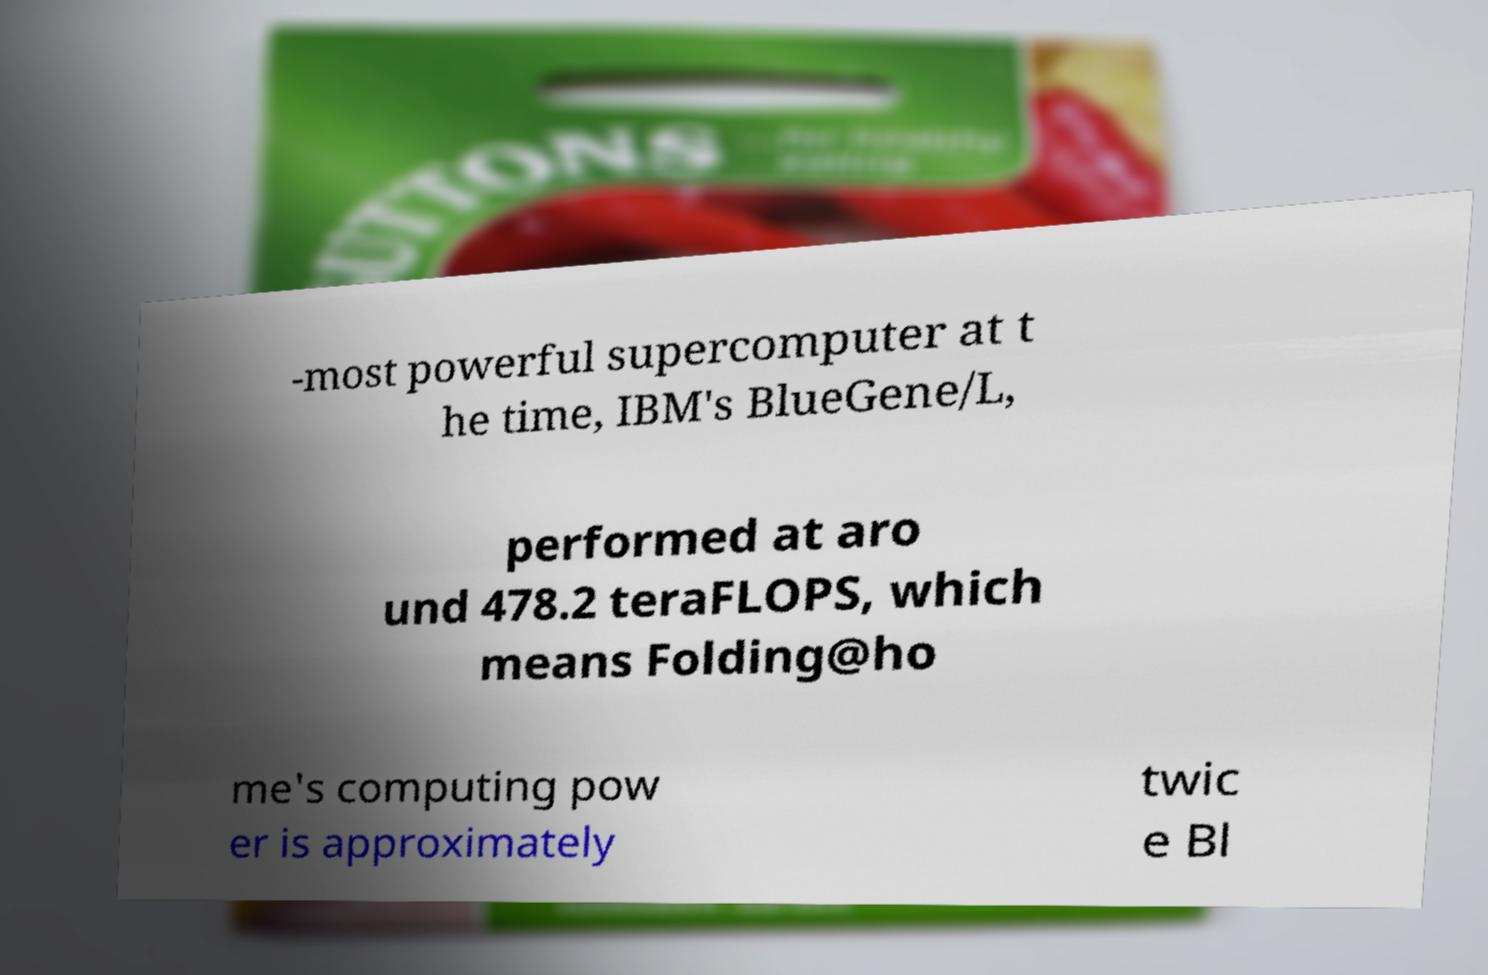Can you read and provide the text displayed in the image?This photo seems to have some interesting text. Can you extract and type it out for me? -most powerful supercomputer at t he time, IBM's BlueGene/L, performed at aro und 478.2 teraFLOPS, which means Folding@ho me's computing pow er is approximately twic e Bl 